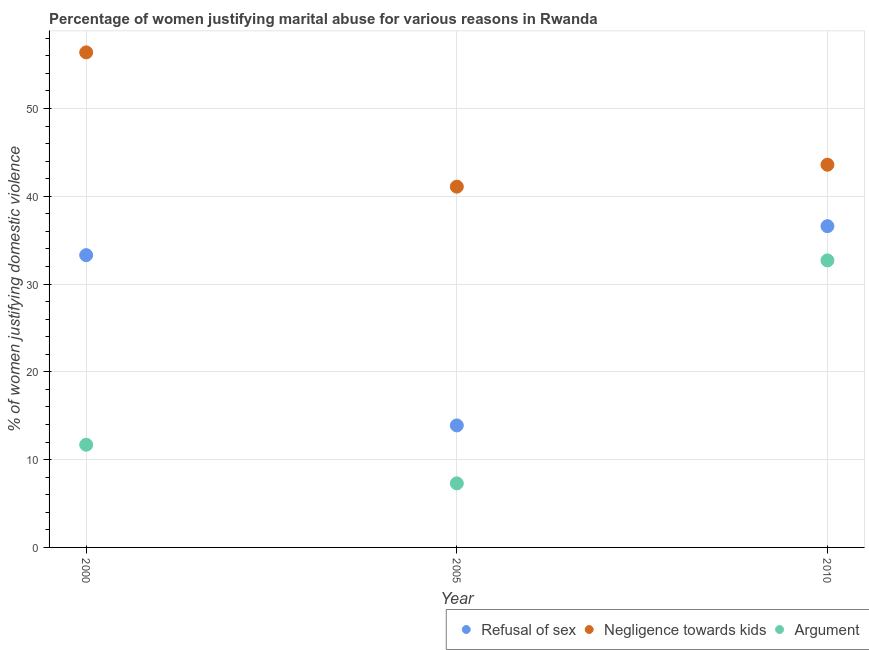What is the percentage of women justifying domestic violence due to arguments in 2000?
Make the answer very short. 11.7. Across all years, what is the maximum percentage of women justifying domestic violence due to arguments?
Your answer should be very brief. 32.7. Across all years, what is the minimum percentage of women justifying domestic violence due to negligence towards kids?
Give a very brief answer. 41.1. In which year was the percentage of women justifying domestic violence due to negligence towards kids minimum?
Your answer should be very brief. 2005. What is the total percentage of women justifying domestic violence due to negligence towards kids in the graph?
Provide a succinct answer. 141.1. What is the difference between the percentage of women justifying domestic violence due to arguments in 2005 and that in 2010?
Give a very brief answer. -25.4. What is the difference between the percentage of women justifying domestic violence due to negligence towards kids in 2000 and the percentage of women justifying domestic violence due to refusal of sex in 2005?
Give a very brief answer. 42.5. What is the average percentage of women justifying domestic violence due to refusal of sex per year?
Make the answer very short. 27.93. In the year 2005, what is the difference between the percentage of women justifying domestic violence due to refusal of sex and percentage of women justifying domestic violence due to arguments?
Your answer should be compact. 6.6. In how many years, is the percentage of women justifying domestic violence due to arguments greater than 14 %?
Your answer should be compact. 1. What is the ratio of the percentage of women justifying domestic violence due to refusal of sex in 2005 to that in 2010?
Your answer should be very brief. 0.38. What is the difference between the highest and the second highest percentage of women justifying domestic violence due to negligence towards kids?
Your answer should be very brief. 12.8. What is the difference between the highest and the lowest percentage of women justifying domestic violence due to arguments?
Offer a terse response. 25.4. Does the percentage of women justifying domestic violence due to arguments monotonically increase over the years?
Provide a succinct answer. No. Is the percentage of women justifying domestic violence due to negligence towards kids strictly greater than the percentage of women justifying domestic violence due to refusal of sex over the years?
Make the answer very short. Yes. How many dotlines are there?
Provide a short and direct response. 3. What is the difference between two consecutive major ticks on the Y-axis?
Provide a short and direct response. 10. Where does the legend appear in the graph?
Your answer should be compact. Bottom right. How are the legend labels stacked?
Your answer should be very brief. Horizontal. What is the title of the graph?
Your response must be concise. Percentage of women justifying marital abuse for various reasons in Rwanda. What is the label or title of the Y-axis?
Offer a terse response. % of women justifying domestic violence. What is the % of women justifying domestic violence in Refusal of sex in 2000?
Your answer should be compact. 33.3. What is the % of women justifying domestic violence in Negligence towards kids in 2000?
Offer a terse response. 56.4. What is the % of women justifying domestic violence in Argument in 2000?
Keep it short and to the point. 11.7. What is the % of women justifying domestic violence in Negligence towards kids in 2005?
Give a very brief answer. 41.1. What is the % of women justifying domestic violence in Argument in 2005?
Your answer should be compact. 7.3. What is the % of women justifying domestic violence of Refusal of sex in 2010?
Your response must be concise. 36.6. What is the % of women justifying domestic violence of Negligence towards kids in 2010?
Offer a very short reply. 43.6. What is the % of women justifying domestic violence in Argument in 2010?
Provide a short and direct response. 32.7. Across all years, what is the maximum % of women justifying domestic violence in Refusal of sex?
Make the answer very short. 36.6. Across all years, what is the maximum % of women justifying domestic violence of Negligence towards kids?
Give a very brief answer. 56.4. Across all years, what is the maximum % of women justifying domestic violence of Argument?
Provide a short and direct response. 32.7. Across all years, what is the minimum % of women justifying domestic violence in Negligence towards kids?
Make the answer very short. 41.1. What is the total % of women justifying domestic violence in Refusal of sex in the graph?
Keep it short and to the point. 83.8. What is the total % of women justifying domestic violence in Negligence towards kids in the graph?
Ensure brevity in your answer.  141.1. What is the total % of women justifying domestic violence in Argument in the graph?
Your answer should be very brief. 51.7. What is the difference between the % of women justifying domestic violence of Refusal of sex in 2000 and that in 2005?
Provide a short and direct response. 19.4. What is the difference between the % of women justifying domestic violence in Negligence towards kids in 2000 and that in 2005?
Make the answer very short. 15.3. What is the difference between the % of women justifying domestic violence in Argument in 2000 and that in 2005?
Offer a terse response. 4.4. What is the difference between the % of women justifying domestic violence of Negligence towards kids in 2000 and that in 2010?
Ensure brevity in your answer.  12.8. What is the difference between the % of women justifying domestic violence in Argument in 2000 and that in 2010?
Your answer should be compact. -21. What is the difference between the % of women justifying domestic violence of Refusal of sex in 2005 and that in 2010?
Offer a terse response. -22.7. What is the difference between the % of women justifying domestic violence of Negligence towards kids in 2005 and that in 2010?
Your response must be concise. -2.5. What is the difference between the % of women justifying domestic violence in Argument in 2005 and that in 2010?
Keep it short and to the point. -25.4. What is the difference between the % of women justifying domestic violence in Refusal of sex in 2000 and the % of women justifying domestic violence in Negligence towards kids in 2005?
Provide a succinct answer. -7.8. What is the difference between the % of women justifying domestic violence in Negligence towards kids in 2000 and the % of women justifying domestic violence in Argument in 2005?
Keep it short and to the point. 49.1. What is the difference between the % of women justifying domestic violence in Refusal of sex in 2000 and the % of women justifying domestic violence in Argument in 2010?
Your answer should be very brief. 0.6. What is the difference between the % of women justifying domestic violence in Negligence towards kids in 2000 and the % of women justifying domestic violence in Argument in 2010?
Offer a terse response. 23.7. What is the difference between the % of women justifying domestic violence in Refusal of sex in 2005 and the % of women justifying domestic violence in Negligence towards kids in 2010?
Provide a short and direct response. -29.7. What is the difference between the % of women justifying domestic violence of Refusal of sex in 2005 and the % of women justifying domestic violence of Argument in 2010?
Keep it short and to the point. -18.8. What is the difference between the % of women justifying domestic violence of Negligence towards kids in 2005 and the % of women justifying domestic violence of Argument in 2010?
Your response must be concise. 8.4. What is the average % of women justifying domestic violence of Refusal of sex per year?
Your response must be concise. 27.93. What is the average % of women justifying domestic violence in Negligence towards kids per year?
Your answer should be very brief. 47.03. What is the average % of women justifying domestic violence of Argument per year?
Ensure brevity in your answer.  17.23. In the year 2000, what is the difference between the % of women justifying domestic violence in Refusal of sex and % of women justifying domestic violence in Negligence towards kids?
Make the answer very short. -23.1. In the year 2000, what is the difference between the % of women justifying domestic violence in Refusal of sex and % of women justifying domestic violence in Argument?
Provide a short and direct response. 21.6. In the year 2000, what is the difference between the % of women justifying domestic violence of Negligence towards kids and % of women justifying domestic violence of Argument?
Provide a short and direct response. 44.7. In the year 2005, what is the difference between the % of women justifying domestic violence in Refusal of sex and % of women justifying domestic violence in Negligence towards kids?
Your answer should be very brief. -27.2. In the year 2005, what is the difference between the % of women justifying domestic violence in Refusal of sex and % of women justifying domestic violence in Argument?
Make the answer very short. 6.6. In the year 2005, what is the difference between the % of women justifying domestic violence of Negligence towards kids and % of women justifying domestic violence of Argument?
Ensure brevity in your answer.  33.8. In the year 2010, what is the difference between the % of women justifying domestic violence in Refusal of sex and % of women justifying domestic violence in Negligence towards kids?
Your answer should be compact. -7. What is the ratio of the % of women justifying domestic violence in Refusal of sex in 2000 to that in 2005?
Keep it short and to the point. 2.4. What is the ratio of the % of women justifying domestic violence in Negligence towards kids in 2000 to that in 2005?
Offer a terse response. 1.37. What is the ratio of the % of women justifying domestic violence in Argument in 2000 to that in 2005?
Keep it short and to the point. 1.6. What is the ratio of the % of women justifying domestic violence in Refusal of sex in 2000 to that in 2010?
Provide a short and direct response. 0.91. What is the ratio of the % of women justifying domestic violence of Negligence towards kids in 2000 to that in 2010?
Keep it short and to the point. 1.29. What is the ratio of the % of women justifying domestic violence of Argument in 2000 to that in 2010?
Offer a terse response. 0.36. What is the ratio of the % of women justifying domestic violence in Refusal of sex in 2005 to that in 2010?
Offer a terse response. 0.38. What is the ratio of the % of women justifying domestic violence in Negligence towards kids in 2005 to that in 2010?
Keep it short and to the point. 0.94. What is the ratio of the % of women justifying domestic violence of Argument in 2005 to that in 2010?
Your response must be concise. 0.22. What is the difference between the highest and the second highest % of women justifying domestic violence of Refusal of sex?
Provide a succinct answer. 3.3. What is the difference between the highest and the second highest % of women justifying domestic violence of Negligence towards kids?
Your response must be concise. 12.8. What is the difference between the highest and the second highest % of women justifying domestic violence in Argument?
Make the answer very short. 21. What is the difference between the highest and the lowest % of women justifying domestic violence of Refusal of sex?
Offer a very short reply. 22.7. What is the difference between the highest and the lowest % of women justifying domestic violence of Argument?
Give a very brief answer. 25.4. 